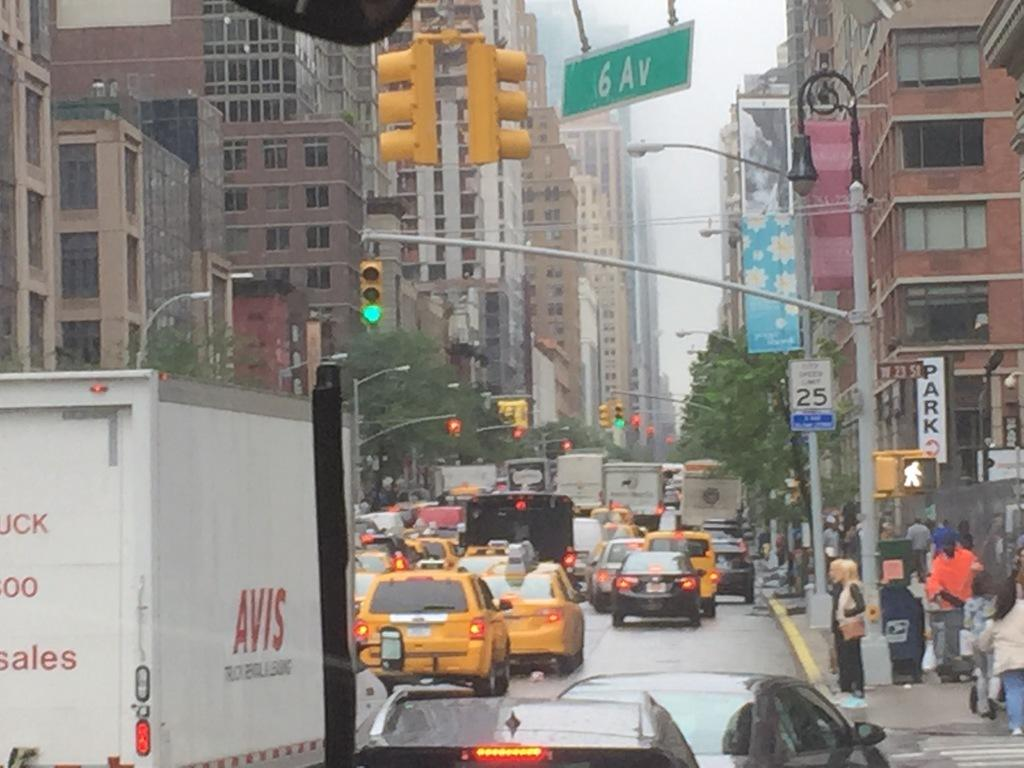<image>
Summarize the visual content of the image. A busy city street with lots of taxis in traffic and a sign that says Park. 